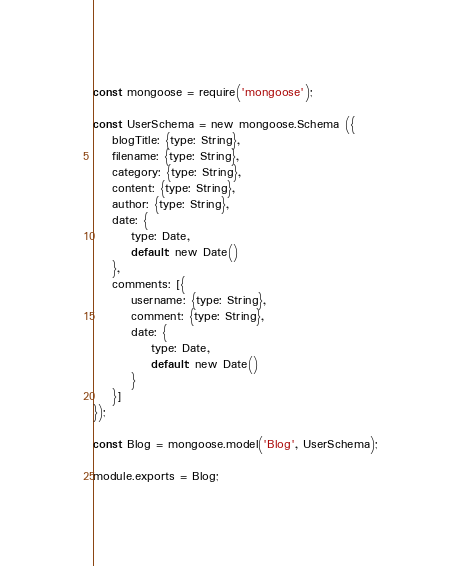<code> <loc_0><loc_0><loc_500><loc_500><_JavaScript_>const mongoose = require('mongoose');

const UserSchema = new mongoose.Schema ({
    blogTitle: {type: String},
    filename: {type: String},
    category: {type: String},
    content: {type: String},
    author: {type: String},
    date: {
        type: Date,
        default: new Date()
    },
    comments: [{
        username: {type: String},
        comment: {type: String},
        date: {
            type: Date,
            default: new Date()
        }
    }]
});

const Blog = mongoose.model('Blog', UserSchema);

module.exports = Blog;</code> 